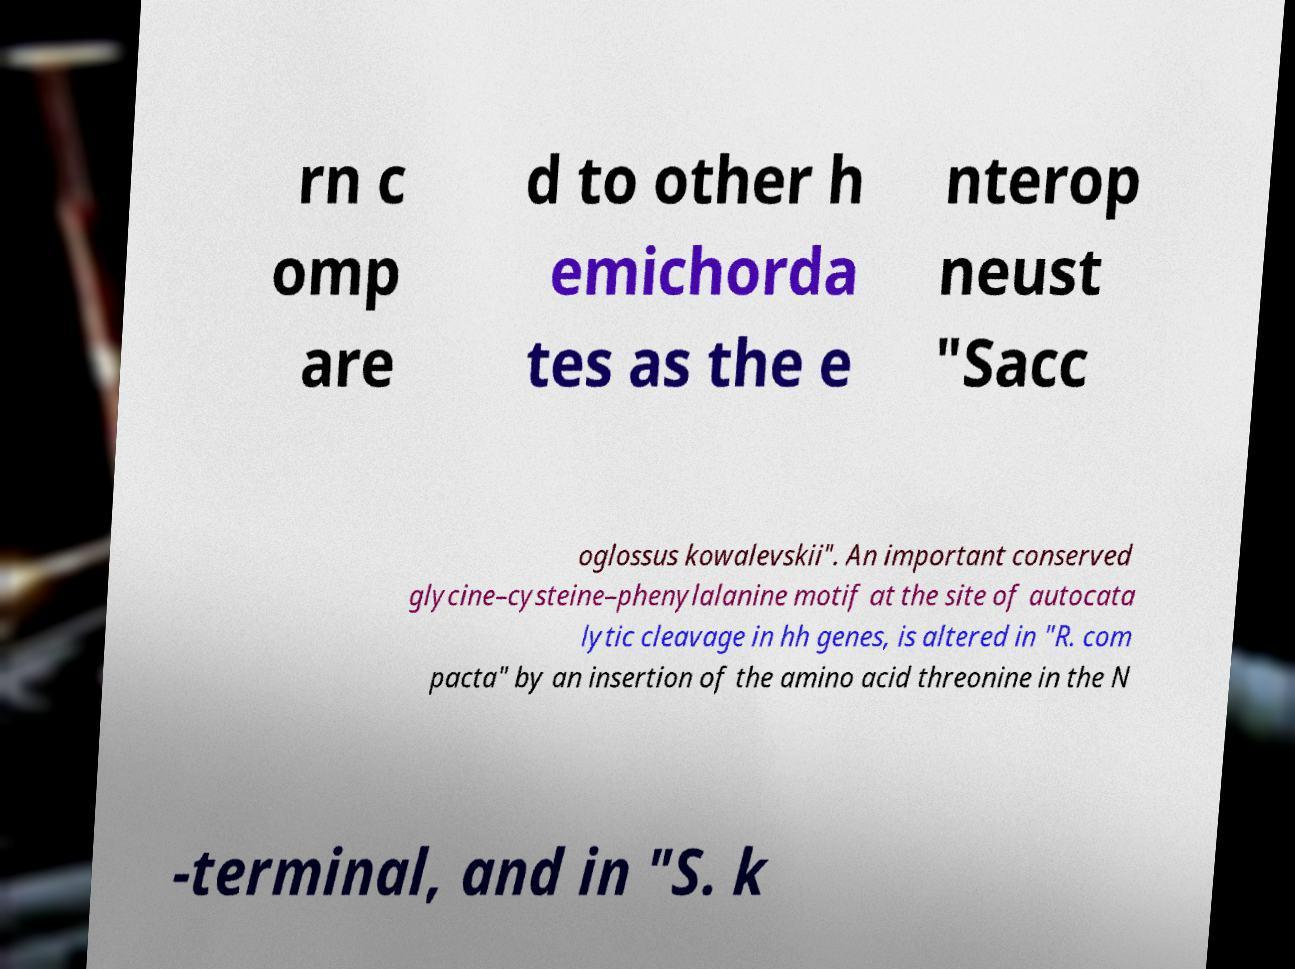Please read and relay the text visible in this image. What does it say? rn c omp are d to other h emichorda tes as the e nterop neust "Sacc oglossus kowalevskii". An important conserved glycine–cysteine–phenylalanine motif at the site of autocata lytic cleavage in hh genes, is altered in "R. com pacta" by an insertion of the amino acid threonine in the N -terminal, and in "S. k 